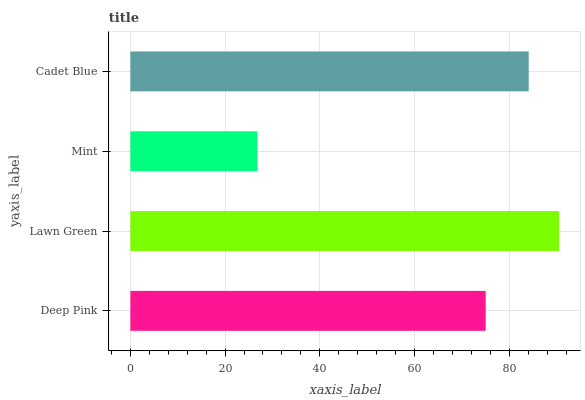Is Mint the minimum?
Answer yes or no. Yes. Is Lawn Green the maximum?
Answer yes or no. Yes. Is Lawn Green the minimum?
Answer yes or no. No. Is Mint the maximum?
Answer yes or no. No. Is Lawn Green greater than Mint?
Answer yes or no. Yes. Is Mint less than Lawn Green?
Answer yes or no. Yes. Is Mint greater than Lawn Green?
Answer yes or no. No. Is Lawn Green less than Mint?
Answer yes or no. No. Is Cadet Blue the high median?
Answer yes or no. Yes. Is Deep Pink the low median?
Answer yes or no. Yes. Is Lawn Green the high median?
Answer yes or no. No. Is Cadet Blue the low median?
Answer yes or no. No. 